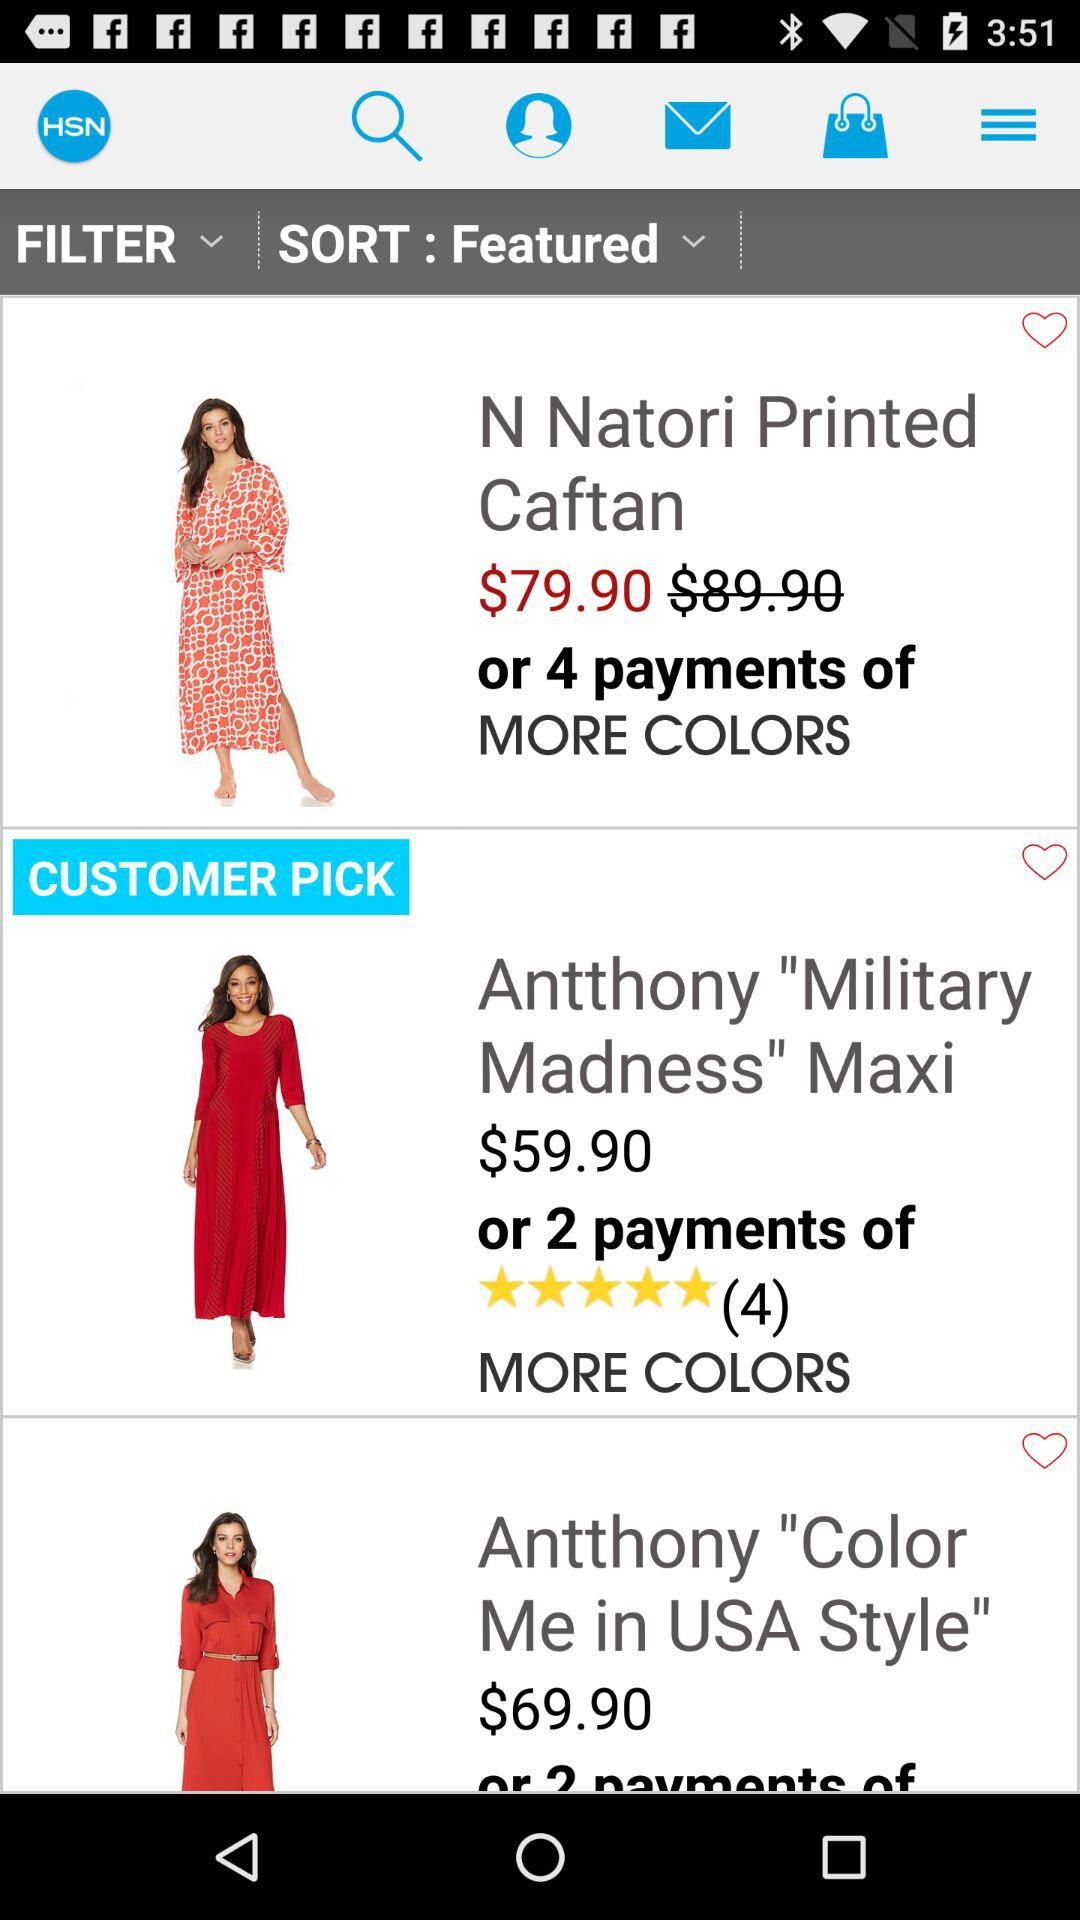What is the discounted price of the "N Natori Printed Caftan"? The discounted price of the "N Natori Printed Caftan" is $79.90. 